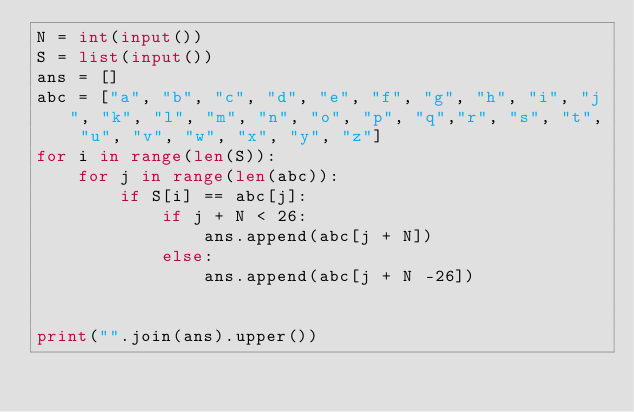<code> <loc_0><loc_0><loc_500><loc_500><_Python_>N = int(input())
S = list(input())
ans = []
abc = ["a", "b", "c", "d", "e", "f", "g", "h", "i", "j", "k", "l", "m", "n", "o", "p", "q","r", "s", "t", "u", "v", "w", "x", "y", "z"]
for i in range(len(S)):
    for j in range(len(abc)):
        if S[i] == abc[j]:
            if j + N < 26:
                ans.append(abc[j + N])
            else:
                ans.append(abc[j + N -26])


print("".join(ans).upper())
</code> 